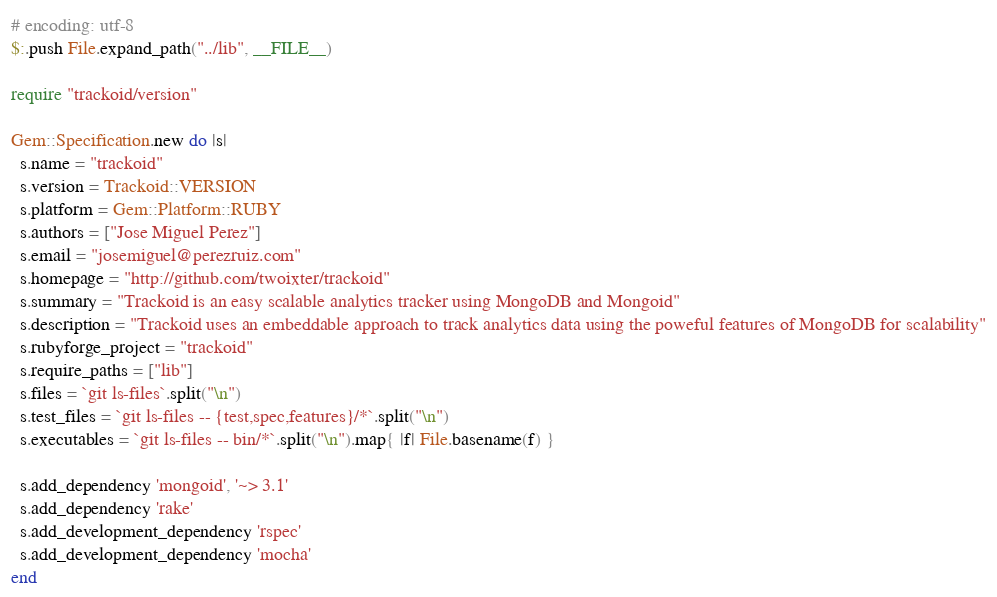Convert code to text. <code><loc_0><loc_0><loc_500><loc_500><_Ruby_># encoding: utf-8
$:.push File.expand_path("../lib", __FILE__)

require "trackoid/version"

Gem::Specification.new do |s|
  s.name = "trackoid"
  s.version = Trackoid::VERSION
  s.platform = Gem::Platform::RUBY
  s.authors = ["Jose Miguel Perez"]
  s.email = "josemiguel@perezruiz.com"
  s.homepage = "http://github.com/twoixter/trackoid"
  s.summary = "Trackoid is an easy scalable analytics tracker using MongoDB and Mongoid"
  s.description = "Trackoid uses an embeddable approach to track analytics data using the poweful features of MongoDB for scalability"
  s.rubyforge_project = "trackoid"
  s.require_paths = ["lib"]
  s.files = `git ls-files`.split("\n")
  s.test_files = `git ls-files -- {test,spec,features}/*`.split("\n")
  s.executables = `git ls-files -- bin/*`.split("\n").map{ |f| File.basename(f) }

  s.add_dependency 'mongoid', '~> 3.1'
  s.add_dependency 'rake'
  s.add_development_dependency 'rspec'
  s.add_development_dependency 'mocha'
end
</code> 